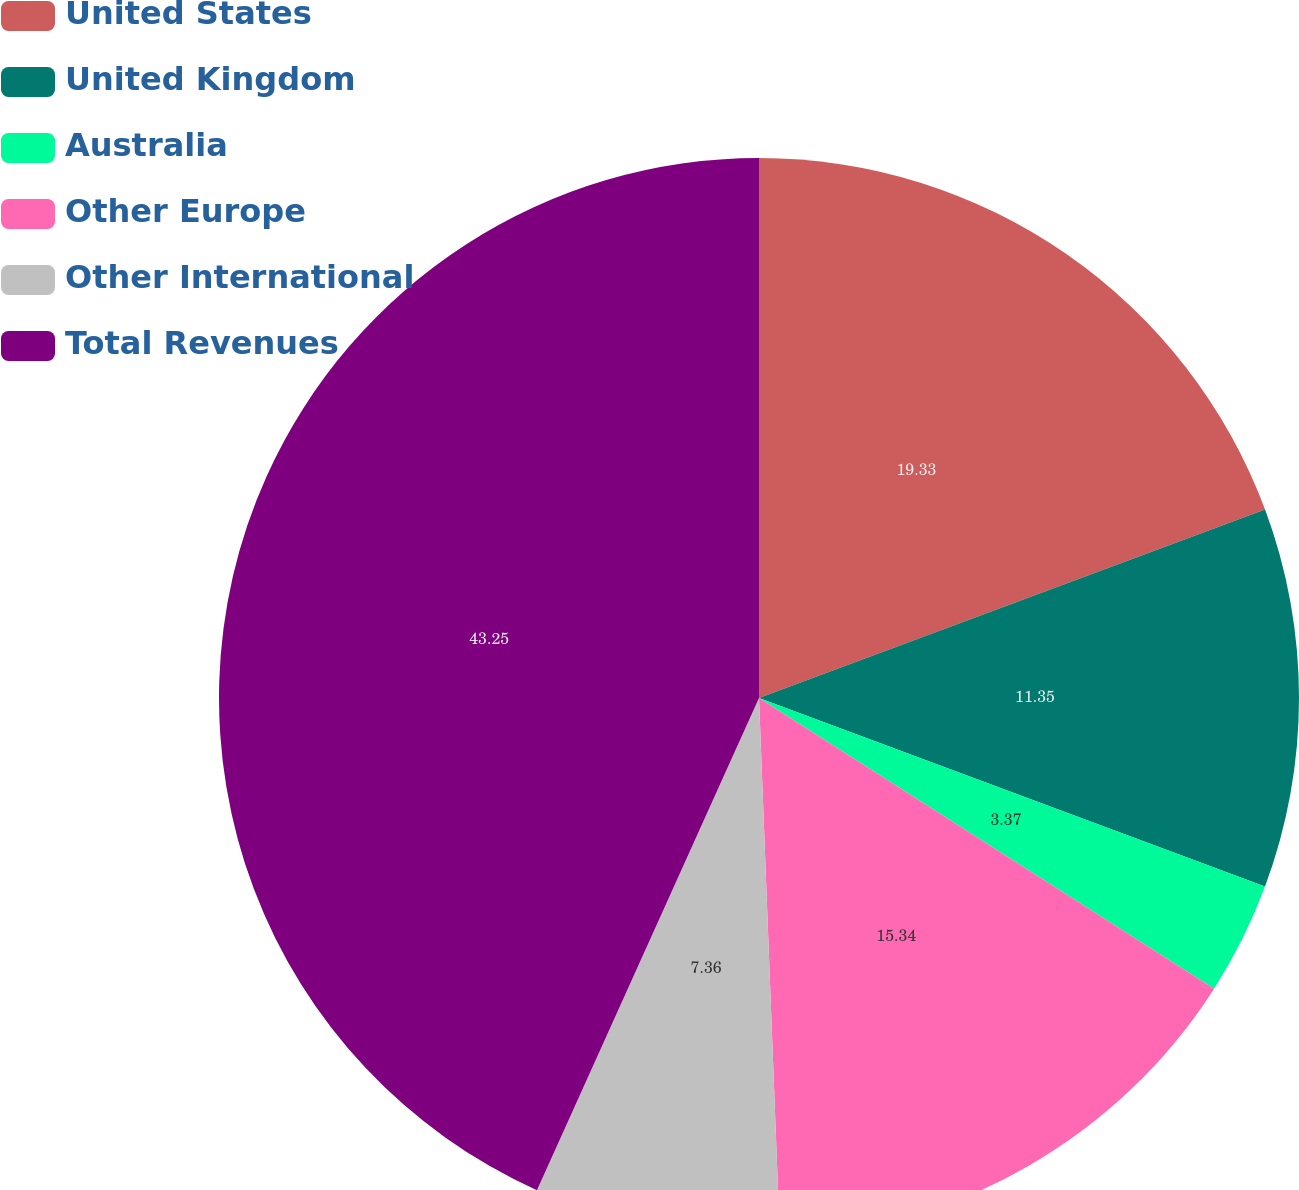<chart> <loc_0><loc_0><loc_500><loc_500><pie_chart><fcel>United States<fcel>United Kingdom<fcel>Australia<fcel>Other Europe<fcel>Other International<fcel>Total Revenues<nl><fcel>19.33%<fcel>11.35%<fcel>3.37%<fcel>15.34%<fcel>7.36%<fcel>43.26%<nl></chart> 